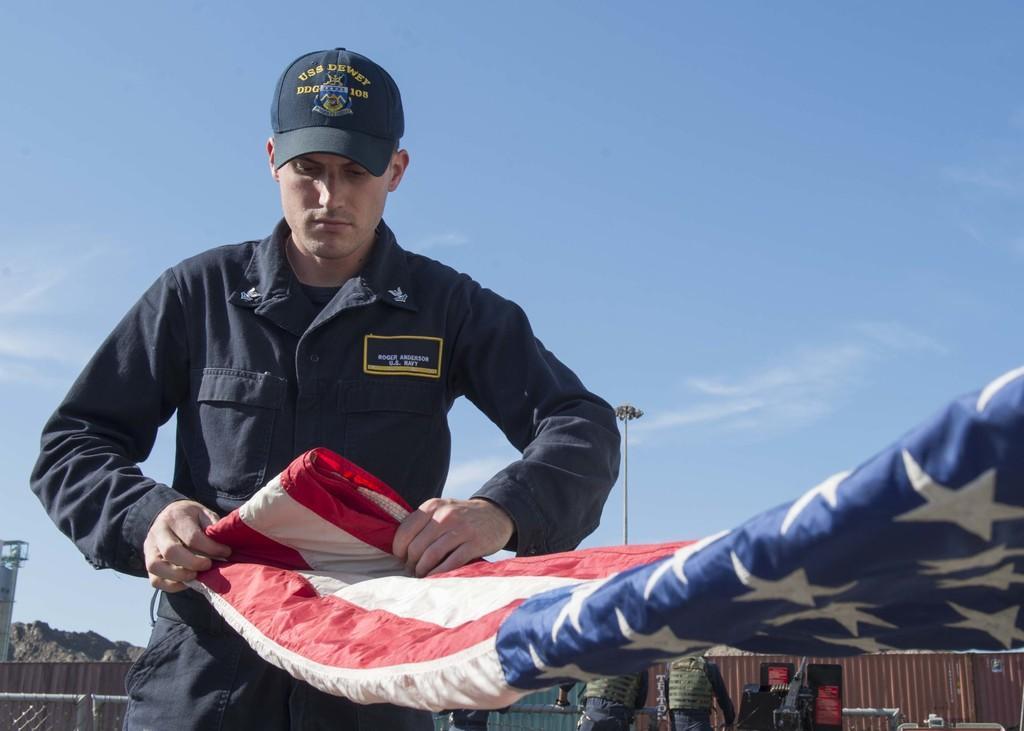Can you describe this image briefly? In this image there is a man standing in the center and folding a flag. In the background there are persons, there is a fence and there is a pole. On the left side in the background there is mountain and the sky is cloudy. 